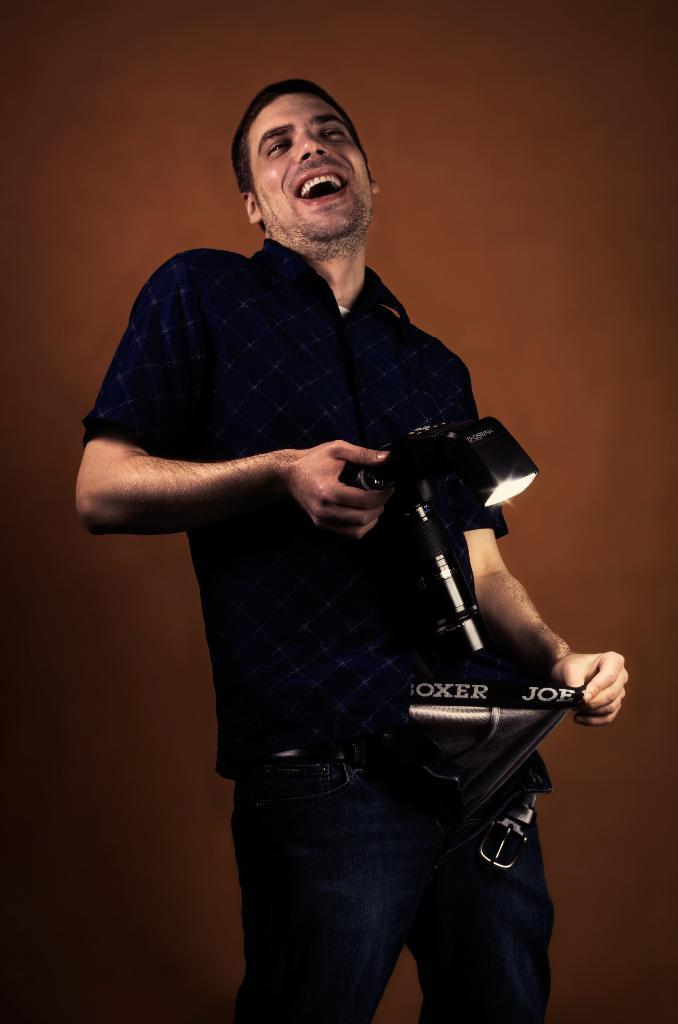Who is present in the image? There is a man in the image. What is the man holding in his hands? The man is holding a camera in his hands. What can be seen in the background of the image? There is a wall in the background of the image. What type of battle is taking place in the image? There is no battle present in the image; it features a man holding a camera. What holiday is being celebrated in the image? There is no indication of a holiday being celebrated in the image. 